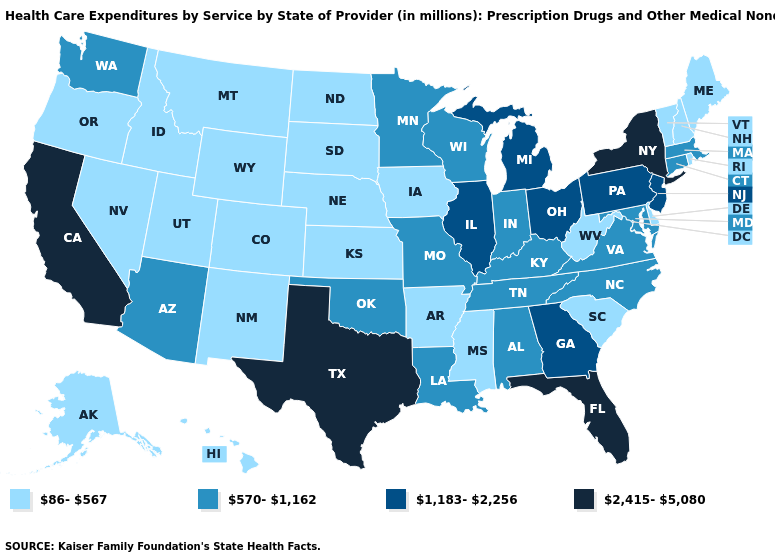What is the lowest value in states that border South Carolina?
Short answer required. 570-1,162. Among the states that border Illinois , which have the highest value?
Be succinct. Indiana, Kentucky, Missouri, Wisconsin. What is the value of Utah?
Quick response, please. 86-567. Among the states that border Massachusetts , which have the highest value?
Answer briefly. New York. Name the states that have a value in the range 86-567?
Give a very brief answer. Alaska, Arkansas, Colorado, Delaware, Hawaii, Idaho, Iowa, Kansas, Maine, Mississippi, Montana, Nebraska, Nevada, New Hampshire, New Mexico, North Dakota, Oregon, Rhode Island, South Carolina, South Dakota, Utah, Vermont, West Virginia, Wyoming. Does the first symbol in the legend represent the smallest category?
Give a very brief answer. Yes. Among the states that border Massachusetts , which have the lowest value?
Be succinct. New Hampshire, Rhode Island, Vermont. Does Florida have the highest value in the South?
Concise answer only. Yes. Among the states that border Arkansas , does Tennessee have the lowest value?
Be succinct. No. Among the states that border Pennsylvania , which have the lowest value?
Keep it brief. Delaware, West Virginia. What is the lowest value in states that border Pennsylvania?
Keep it brief. 86-567. Name the states that have a value in the range 570-1,162?
Keep it brief. Alabama, Arizona, Connecticut, Indiana, Kentucky, Louisiana, Maryland, Massachusetts, Minnesota, Missouri, North Carolina, Oklahoma, Tennessee, Virginia, Washington, Wisconsin. Which states have the lowest value in the MidWest?
Write a very short answer. Iowa, Kansas, Nebraska, North Dakota, South Dakota. What is the lowest value in states that border Wyoming?
Quick response, please. 86-567. 